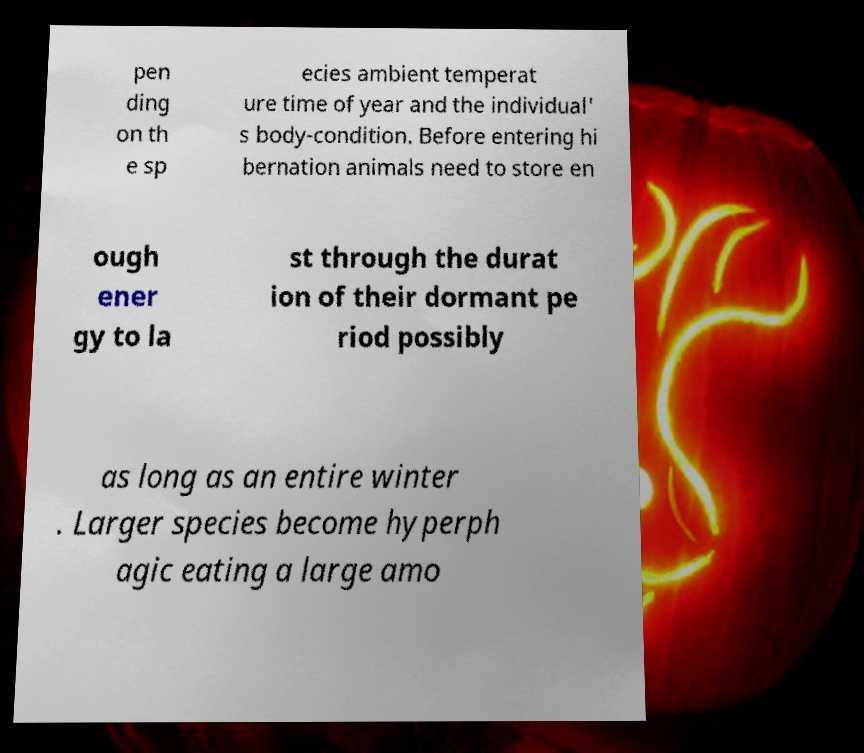Please identify and transcribe the text found in this image. pen ding on th e sp ecies ambient temperat ure time of year and the individual' s body-condition. Before entering hi bernation animals need to store en ough ener gy to la st through the durat ion of their dormant pe riod possibly as long as an entire winter . Larger species become hyperph agic eating a large amo 